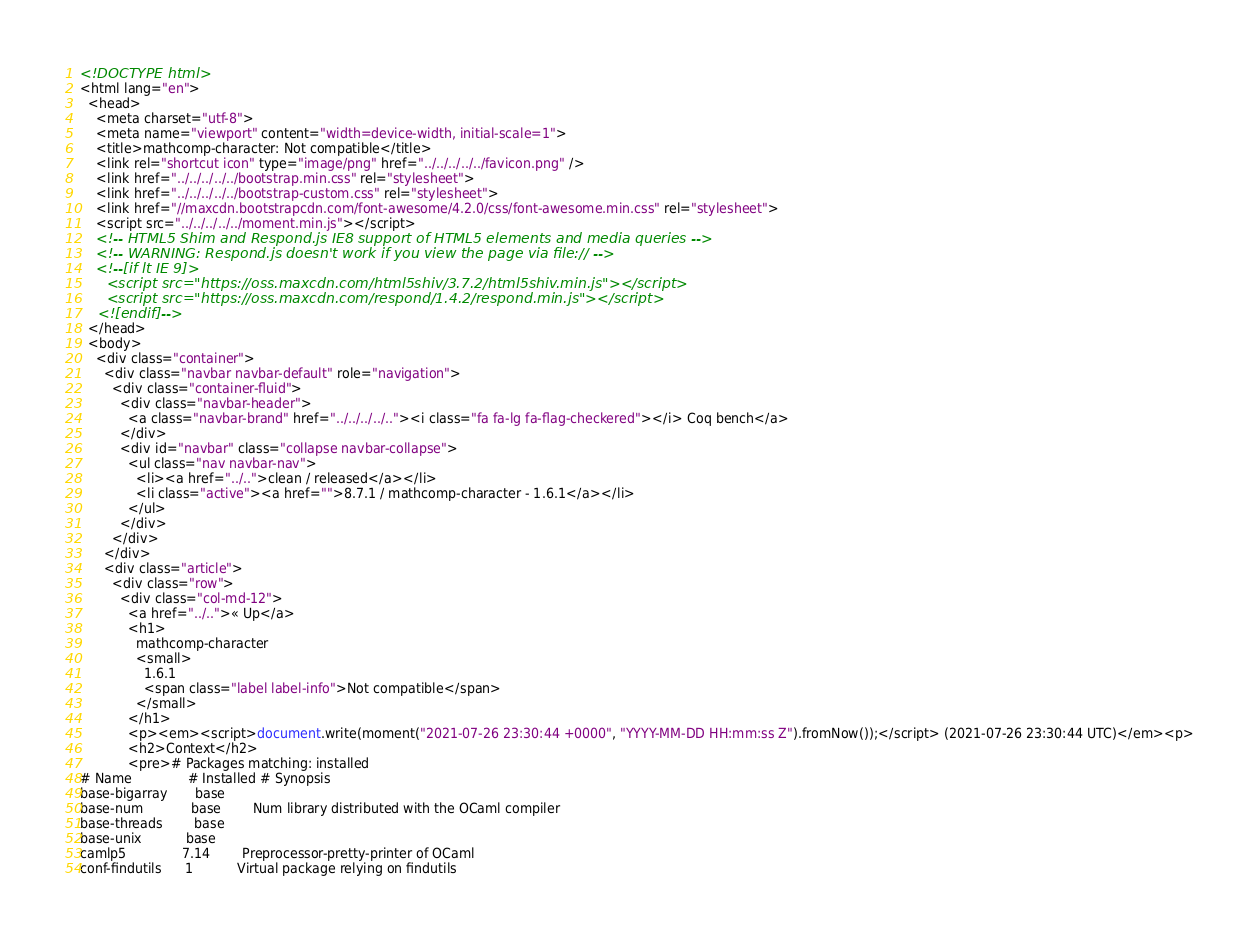<code> <loc_0><loc_0><loc_500><loc_500><_HTML_><!DOCTYPE html>
<html lang="en">
  <head>
    <meta charset="utf-8">
    <meta name="viewport" content="width=device-width, initial-scale=1">
    <title>mathcomp-character: Not compatible</title>
    <link rel="shortcut icon" type="image/png" href="../../../../../favicon.png" />
    <link href="../../../../../bootstrap.min.css" rel="stylesheet">
    <link href="../../../../../bootstrap-custom.css" rel="stylesheet">
    <link href="//maxcdn.bootstrapcdn.com/font-awesome/4.2.0/css/font-awesome.min.css" rel="stylesheet">
    <script src="../../../../../moment.min.js"></script>
    <!-- HTML5 Shim and Respond.js IE8 support of HTML5 elements and media queries -->
    <!-- WARNING: Respond.js doesn't work if you view the page via file:// -->
    <!--[if lt IE 9]>
      <script src="https://oss.maxcdn.com/html5shiv/3.7.2/html5shiv.min.js"></script>
      <script src="https://oss.maxcdn.com/respond/1.4.2/respond.min.js"></script>
    <![endif]-->
  </head>
  <body>
    <div class="container">
      <div class="navbar navbar-default" role="navigation">
        <div class="container-fluid">
          <div class="navbar-header">
            <a class="navbar-brand" href="../../../../.."><i class="fa fa-lg fa-flag-checkered"></i> Coq bench</a>
          </div>
          <div id="navbar" class="collapse navbar-collapse">
            <ul class="nav navbar-nav">
              <li><a href="../..">clean / released</a></li>
              <li class="active"><a href="">8.7.1 / mathcomp-character - 1.6.1</a></li>
            </ul>
          </div>
        </div>
      </div>
      <div class="article">
        <div class="row">
          <div class="col-md-12">
            <a href="../..">« Up</a>
            <h1>
              mathcomp-character
              <small>
                1.6.1
                <span class="label label-info">Not compatible</span>
              </small>
            </h1>
            <p><em><script>document.write(moment("2021-07-26 23:30:44 +0000", "YYYY-MM-DD HH:mm:ss Z").fromNow());</script> (2021-07-26 23:30:44 UTC)</em><p>
            <h2>Context</h2>
            <pre># Packages matching: installed
# Name              # Installed # Synopsis
base-bigarray       base
base-num            base        Num library distributed with the OCaml compiler
base-threads        base
base-unix           base
camlp5              7.14        Preprocessor-pretty-printer of OCaml
conf-findutils      1           Virtual package relying on findutils</code> 